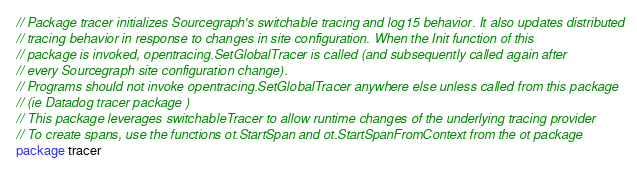<code> <loc_0><loc_0><loc_500><loc_500><_Go_>// Package tracer initializes Sourcegraph's switchable tracing and log15 behavior. It also updates distributed
// tracing behavior in response to changes in site configuration. When the Init function of this
// package is invoked, opentracing.SetGlobalTracer is called (and subsequently called again after
// every Sourcegraph site configuration change).
// Programs should not invoke opentracing.SetGlobalTracer anywhere else unless called from this package
// (ie Datadog tracer package )
// This package leverages switchableTracer to allow runtime changes of the underlying tracing provider
// To create spans, use the functions ot.StartSpan and ot.StartSpanFromContext from the ot package
package tracer
</code> 